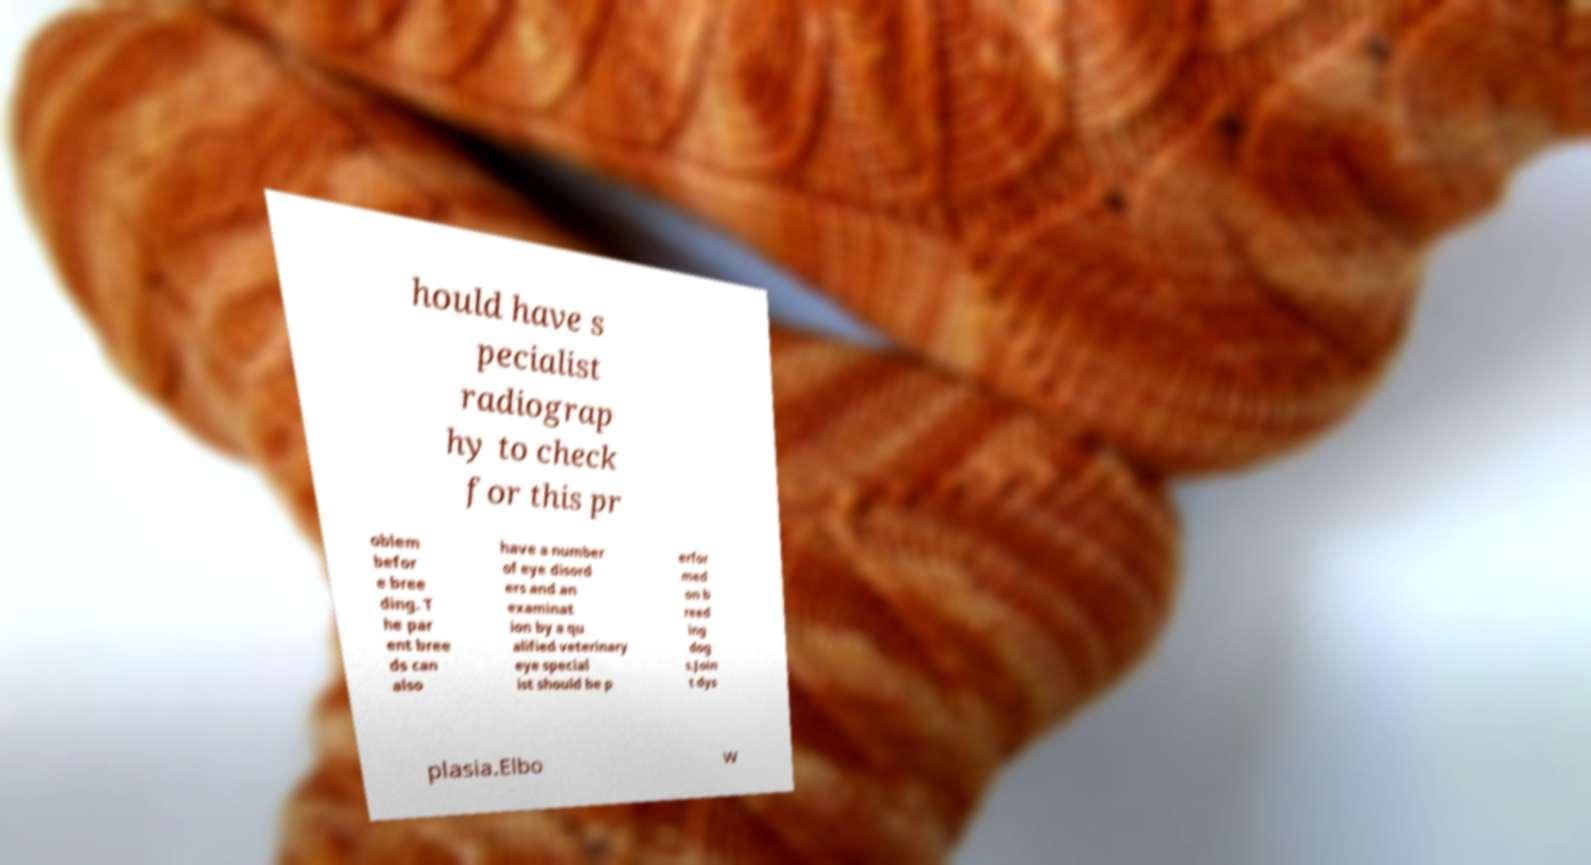Please identify and transcribe the text found in this image. hould have s pecialist radiograp hy to check for this pr oblem befor e bree ding. T he par ent bree ds can also have a number of eye disord ers and an examinat ion by a qu alified veterinary eye special ist should be p erfor med on b reed ing dog s.Join t dys plasia.Elbo w 